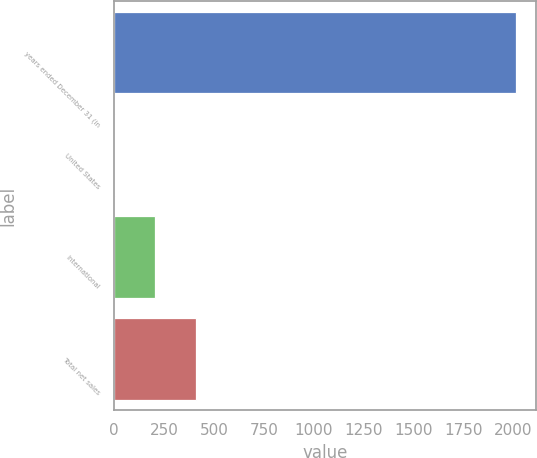Convert chart. <chart><loc_0><loc_0><loc_500><loc_500><bar_chart><fcel>years ended December 31 (in<fcel>United States<fcel>International<fcel>Total net sales<nl><fcel>2013<fcel>7<fcel>207.6<fcel>408.2<nl></chart> 